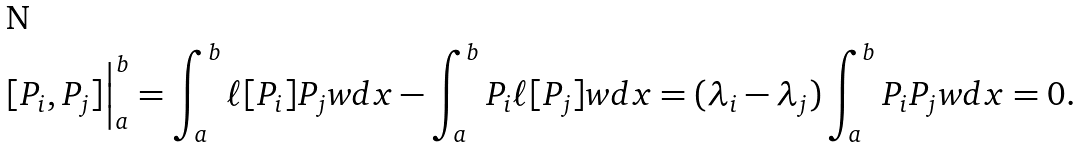<formula> <loc_0><loc_0><loc_500><loc_500>[ P _ { i } , P _ { j } ] \Big | _ { a } ^ { b } & = \int _ { a } ^ { b } \ell [ P _ { i } ] P _ { j } w d x - \int _ { a } ^ { b } P _ { i } \ell [ P _ { j } ] w d x = ( \lambda _ { i } - \lambda _ { j } ) \int _ { a } ^ { b } P _ { i } P _ { j } w d x = 0 .</formula> 